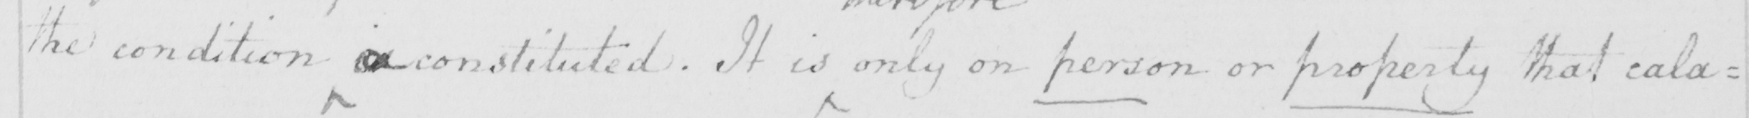Please transcribe the handwritten text in this image. the condition is constituted . It is only on person or property that cala= 